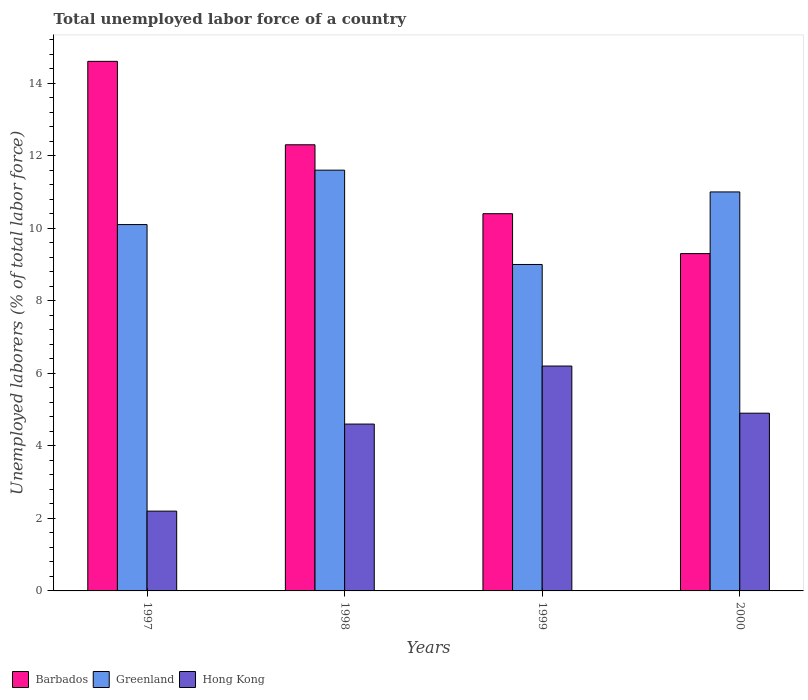Are the number of bars per tick equal to the number of legend labels?
Offer a very short reply. Yes. Are the number of bars on each tick of the X-axis equal?
Give a very brief answer. Yes. How many bars are there on the 2nd tick from the right?
Provide a short and direct response. 3. What is the label of the 1st group of bars from the left?
Provide a short and direct response. 1997. What is the total unemployed labor force in Barbados in 1998?
Offer a very short reply. 12.3. Across all years, what is the maximum total unemployed labor force in Hong Kong?
Make the answer very short. 6.2. Across all years, what is the minimum total unemployed labor force in Greenland?
Keep it short and to the point. 9. What is the total total unemployed labor force in Hong Kong in the graph?
Ensure brevity in your answer.  17.9. What is the difference between the total unemployed labor force in Barbados in 1998 and that in 1999?
Your answer should be very brief. 1.9. What is the difference between the total unemployed labor force in Barbados in 2000 and the total unemployed labor force in Hong Kong in 1998?
Provide a succinct answer. 4.7. What is the average total unemployed labor force in Hong Kong per year?
Offer a terse response. 4.47. In the year 2000, what is the difference between the total unemployed labor force in Barbados and total unemployed labor force in Greenland?
Provide a succinct answer. -1.7. In how many years, is the total unemployed labor force in Greenland greater than 9.6 %?
Make the answer very short. 3. What is the ratio of the total unemployed labor force in Hong Kong in 1999 to that in 2000?
Keep it short and to the point. 1.27. What is the difference between the highest and the second highest total unemployed labor force in Greenland?
Keep it short and to the point. 0.6. What is the difference between the highest and the lowest total unemployed labor force in Hong Kong?
Make the answer very short. 4. In how many years, is the total unemployed labor force in Greenland greater than the average total unemployed labor force in Greenland taken over all years?
Your answer should be very brief. 2. What does the 1st bar from the left in 1999 represents?
Keep it short and to the point. Barbados. What does the 2nd bar from the right in 1999 represents?
Make the answer very short. Greenland. How many bars are there?
Your answer should be very brief. 12. How many years are there in the graph?
Ensure brevity in your answer.  4. What is the difference between two consecutive major ticks on the Y-axis?
Your response must be concise. 2. Does the graph contain any zero values?
Offer a terse response. No. Does the graph contain grids?
Give a very brief answer. No. Where does the legend appear in the graph?
Keep it short and to the point. Bottom left. What is the title of the graph?
Offer a very short reply. Total unemployed labor force of a country. Does "Lebanon" appear as one of the legend labels in the graph?
Ensure brevity in your answer.  No. What is the label or title of the Y-axis?
Your response must be concise. Unemployed laborers (% of total labor force). What is the Unemployed laborers (% of total labor force) in Barbados in 1997?
Provide a short and direct response. 14.6. What is the Unemployed laborers (% of total labor force) of Greenland in 1997?
Give a very brief answer. 10.1. What is the Unemployed laborers (% of total labor force) in Hong Kong in 1997?
Ensure brevity in your answer.  2.2. What is the Unemployed laborers (% of total labor force) in Barbados in 1998?
Give a very brief answer. 12.3. What is the Unemployed laborers (% of total labor force) of Greenland in 1998?
Your answer should be very brief. 11.6. What is the Unemployed laborers (% of total labor force) of Hong Kong in 1998?
Keep it short and to the point. 4.6. What is the Unemployed laborers (% of total labor force) in Barbados in 1999?
Provide a short and direct response. 10.4. What is the Unemployed laborers (% of total labor force) in Hong Kong in 1999?
Provide a succinct answer. 6.2. What is the Unemployed laborers (% of total labor force) in Barbados in 2000?
Provide a short and direct response. 9.3. What is the Unemployed laborers (% of total labor force) in Hong Kong in 2000?
Ensure brevity in your answer.  4.9. Across all years, what is the maximum Unemployed laborers (% of total labor force) of Barbados?
Keep it short and to the point. 14.6. Across all years, what is the maximum Unemployed laborers (% of total labor force) in Greenland?
Offer a terse response. 11.6. Across all years, what is the maximum Unemployed laborers (% of total labor force) of Hong Kong?
Your answer should be compact. 6.2. Across all years, what is the minimum Unemployed laborers (% of total labor force) of Barbados?
Provide a short and direct response. 9.3. Across all years, what is the minimum Unemployed laborers (% of total labor force) of Greenland?
Your answer should be compact. 9. Across all years, what is the minimum Unemployed laborers (% of total labor force) of Hong Kong?
Offer a very short reply. 2.2. What is the total Unemployed laborers (% of total labor force) of Barbados in the graph?
Offer a terse response. 46.6. What is the total Unemployed laborers (% of total labor force) of Greenland in the graph?
Your response must be concise. 41.7. What is the difference between the Unemployed laborers (% of total labor force) of Greenland in 1997 and that in 1999?
Keep it short and to the point. 1.1. What is the difference between the Unemployed laborers (% of total labor force) of Hong Kong in 1997 and that in 1999?
Keep it short and to the point. -4. What is the difference between the Unemployed laborers (% of total labor force) in Barbados in 1997 and that in 2000?
Your response must be concise. 5.3. What is the difference between the Unemployed laborers (% of total labor force) in Greenland in 1997 and that in 2000?
Make the answer very short. -0.9. What is the difference between the Unemployed laborers (% of total labor force) of Hong Kong in 1997 and that in 2000?
Ensure brevity in your answer.  -2.7. What is the difference between the Unemployed laborers (% of total labor force) of Greenland in 1998 and that in 1999?
Your answer should be very brief. 2.6. What is the difference between the Unemployed laborers (% of total labor force) of Barbados in 1998 and that in 2000?
Provide a succinct answer. 3. What is the difference between the Unemployed laborers (% of total labor force) in Greenland in 1998 and that in 2000?
Offer a terse response. 0.6. What is the difference between the Unemployed laborers (% of total labor force) in Barbados in 1999 and that in 2000?
Give a very brief answer. 1.1. What is the difference between the Unemployed laborers (% of total labor force) of Greenland in 1999 and that in 2000?
Your answer should be very brief. -2. What is the difference between the Unemployed laborers (% of total labor force) of Barbados in 1997 and the Unemployed laborers (% of total labor force) of Greenland in 1998?
Give a very brief answer. 3. What is the difference between the Unemployed laborers (% of total labor force) in Greenland in 1997 and the Unemployed laborers (% of total labor force) in Hong Kong in 1998?
Ensure brevity in your answer.  5.5. What is the difference between the Unemployed laborers (% of total labor force) of Barbados in 1997 and the Unemployed laborers (% of total labor force) of Hong Kong in 1999?
Provide a short and direct response. 8.4. What is the difference between the Unemployed laborers (% of total labor force) of Barbados in 1998 and the Unemployed laborers (% of total labor force) of Greenland in 1999?
Provide a short and direct response. 3.3. What is the difference between the Unemployed laborers (% of total labor force) in Greenland in 1998 and the Unemployed laborers (% of total labor force) in Hong Kong in 1999?
Ensure brevity in your answer.  5.4. What is the difference between the Unemployed laborers (% of total labor force) in Barbados in 1998 and the Unemployed laborers (% of total labor force) in Hong Kong in 2000?
Offer a terse response. 7.4. What is the difference between the Unemployed laborers (% of total labor force) of Greenland in 1998 and the Unemployed laborers (% of total labor force) of Hong Kong in 2000?
Offer a terse response. 6.7. What is the difference between the Unemployed laborers (% of total labor force) in Barbados in 1999 and the Unemployed laborers (% of total labor force) in Greenland in 2000?
Your response must be concise. -0.6. What is the difference between the Unemployed laborers (% of total labor force) of Barbados in 1999 and the Unemployed laborers (% of total labor force) of Hong Kong in 2000?
Provide a short and direct response. 5.5. What is the average Unemployed laborers (% of total labor force) in Barbados per year?
Offer a very short reply. 11.65. What is the average Unemployed laborers (% of total labor force) in Greenland per year?
Offer a very short reply. 10.43. What is the average Unemployed laborers (% of total labor force) of Hong Kong per year?
Provide a short and direct response. 4.47. In the year 1997, what is the difference between the Unemployed laborers (% of total labor force) of Barbados and Unemployed laborers (% of total labor force) of Hong Kong?
Give a very brief answer. 12.4. In the year 1997, what is the difference between the Unemployed laborers (% of total labor force) in Greenland and Unemployed laborers (% of total labor force) in Hong Kong?
Give a very brief answer. 7.9. In the year 1998, what is the difference between the Unemployed laborers (% of total labor force) of Barbados and Unemployed laborers (% of total labor force) of Greenland?
Offer a very short reply. 0.7. In the year 1998, what is the difference between the Unemployed laborers (% of total labor force) in Barbados and Unemployed laborers (% of total labor force) in Hong Kong?
Offer a very short reply. 7.7. In the year 1999, what is the difference between the Unemployed laborers (% of total labor force) in Barbados and Unemployed laborers (% of total labor force) in Hong Kong?
Provide a succinct answer. 4.2. In the year 2000, what is the difference between the Unemployed laborers (% of total labor force) of Barbados and Unemployed laborers (% of total labor force) of Greenland?
Keep it short and to the point. -1.7. In the year 2000, what is the difference between the Unemployed laborers (% of total labor force) in Barbados and Unemployed laborers (% of total labor force) in Hong Kong?
Provide a short and direct response. 4.4. In the year 2000, what is the difference between the Unemployed laborers (% of total labor force) of Greenland and Unemployed laborers (% of total labor force) of Hong Kong?
Your answer should be very brief. 6.1. What is the ratio of the Unemployed laborers (% of total labor force) in Barbados in 1997 to that in 1998?
Give a very brief answer. 1.19. What is the ratio of the Unemployed laborers (% of total labor force) in Greenland in 1997 to that in 1998?
Your response must be concise. 0.87. What is the ratio of the Unemployed laborers (% of total labor force) of Hong Kong in 1997 to that in 1998?
Offer a very short reply. 0.48. What is the ratio of the Unemployed laborers (% of total labor force) of Barbados in 1997 to that in 1999?
Keep it short and to the point. 1.4. What is the ratio of the Unemployed laborers (% of total labor force) in Greenland in 1997 to that in 1999?
Make the answer very short. 1.12. What is the ratio of the Unemployed laborers (% of total labor force) in Hong Kong in 1997 to that in 1999?
Your response must be concise. 0.35. What is the ratio of the Unemployed laborers (% of total labor force) in Barbados in 1997 to that in 2000?
Your response must be concise. 1.57. What is the ratio of the Unemployed laborers (% of total labor force) in Greenland in 1997 to that in 2000?
Give a very brief answer. 0.92. What is the ratio of the Unemployed laborers (% of total labor force) in Hong Kong in 1997 to that in 2000?
Offer a very short reply. 0.45. What is the ratio of the Unemployed laborers (% of total labor force) of Barbados in 1998 to that in 1999?
Your answer should be compact. 1.18. What is the ratio of the Unemployed laborers (% of total labor force) of Greenland in 1998 to that in 1999?
Offer a very short reply. 1.29. What is the ratio of the Unemployed laborers (% of total labor force) of Hong Kong in 1998 to that in 1999?
Offer a very short reply. 0.74. What is the ratio of the Unemployed laborers (% of total labor force) of Barbados in 1998 to that in 2000?
Offer a terse response. 1.32. What is the ratio of the Unemployed laborers (% of total labor force) of Greenland in 1998 to that in 2000?
Your answer should be very brief. 1.05. What is the ratio of the Unemployed laborers (% of total labor force) of Hong Kong in 1998 to that in 2000?
Ensure brevity in your answer.  0.94. What is the ratio of the Unemployed laborers (% of total labor force) in Barbados in 1999 to that in 2000?
Provide a short and direct response. 1.12. What is the ratio of the Unemployed laborers (% of total labor force) of Greenland in 1999 to that in 2000?
Make the answer very short. 0.82. What is the ratio of the Unemployed laborers (% of total labor force) in Hong Kong in 1999 to that in 2000?
Make the answer very short. 1.27. What is the difference between the highest and the second highest Unemployed laborers (% of total labor force) in Barbados?
Your response must be concise. 2.3. What is the difference between the highest and the second highest Unemployed laborers (% of total labor force) in Greenland?
Provide a succinct answer. 0.6. What is the difference between the highest and the lowest Unemployed laborers (% of total labor force) in Barbados?
Offer a very short reply. 5.3. What is the difference between the highest and the lowest Unemployed laborers (% of total labor force) in Greenland?
Make the answer very short. 2.6. 